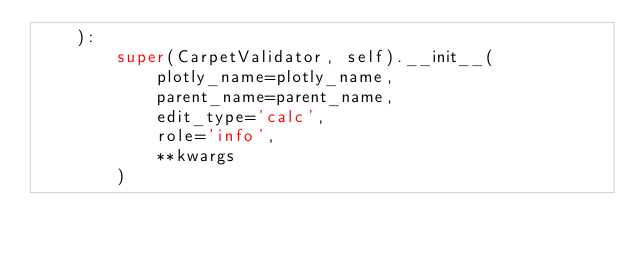<code> <loc_0><loc_0><loc_500><loc_500><_Python_>    ):
        super(CarpetValidator, self).__init__(
            plotly_name=plotly_name,
            parent_name=parent_name,
            edit_type='calc',
            role='info',
            **kwargs
        )
</code> 